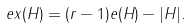Convert formula to latex. <formula><loc_0><loc_0><loc_500><loc_500>\ e x ( H ) & = ( r - 1 ) e ( H ) - | H | .</formula> 